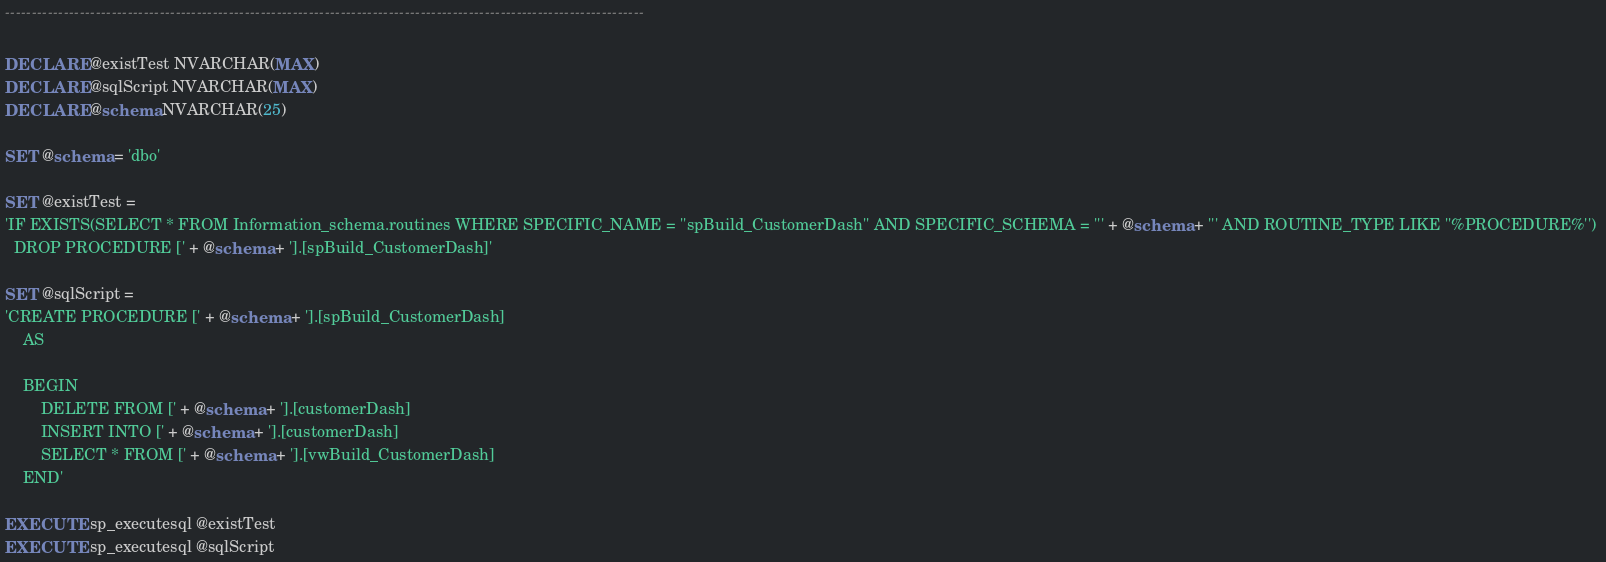<code> <loc_0><loc_0><loc_500><loc_500><_SQL_>------------------------------------------------------------------------------------------------------------------------

DECLARE @existTest NVARCHAR(MAX)
DECLARE @sqlScript NVARCHAR(MAX)
DECLARE @schema NVARCHAR(25)

SET @schema = 'dbo'

SET @existTest = 
'IF EXISTS(SELECT * FROM Information_schema.routines WHERE SPECIFIC_NAME = ''spBuild_CustomerDash'' AND SPECIFIC_SCHEMA = ''' + @schema + ''' AND ROUTINE_TYPE LIKE ''%PROCEDURE%'') 
  DROP PROCEDURE [' + @schema + '].[spBuild_CustomerDash]'

SET @sqlScript = 
'CREATE PROCEDURE [' + @schema + '].[spBuild_CustomerDash]
	AS 

	BEGIN
		DELETE FROM [' + @schema + '].[customerDash]
		INSERT INTO [' + @schema + '].[customerDash]
		SELECT * FROM [' + @schema + '].[vwBuild_CustomerDash]
	END'

EXECUTE sp_executesql @existTest
EXECUTE sp_executesql @sqlScript
</code> 